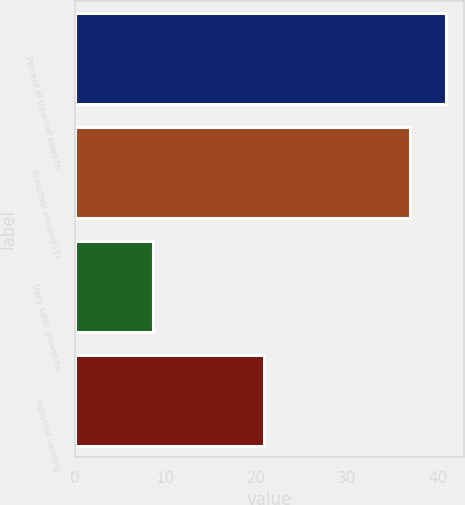Convert chart to OTSL. <chart><loc_0><loc_0><loc_500><loc_500><bar_chart><fcel>Percent of total net sales to<fcel>industrial vending (1)<fcel>Daily sales growth to<fcel>industrial vending<nl><fcel>40.9<fcel>37<fcel>8.6<fcel>20.9<nl></chart> 